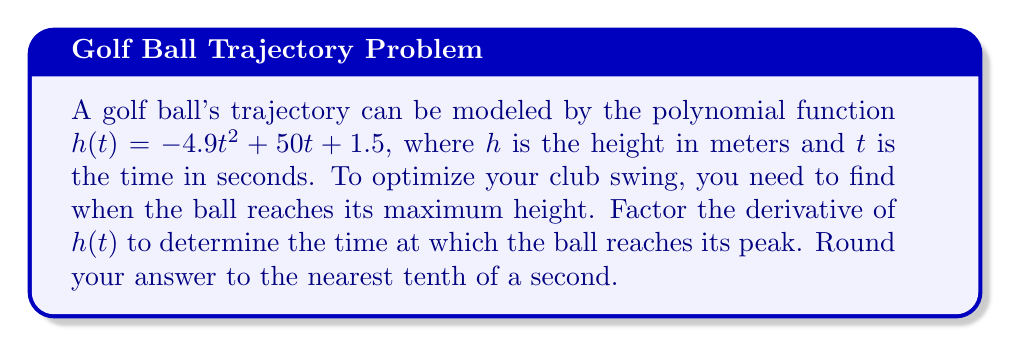Solve this math problem. 1) First, we need to find the derivative of $h(t)$:
   $h'(t) = -9.8t + 50$

2) To find the maximum height, we need to find where $h'(t) = 0$:
   $-9.8t + 50 = 0$

3) Factor out the common factor:
   $-9.8(t - \frac{50}{9.8}) = 0$

4) Solve for t:
   $t - \frac{50}{9.8} = 0$
   $t = \frac{50}{9.8} \approx 5.1020408163265$

5) Rounding to the nearest tenth:
   $t \approx 5.1$ seconds
Answer: 5.1 seconds 